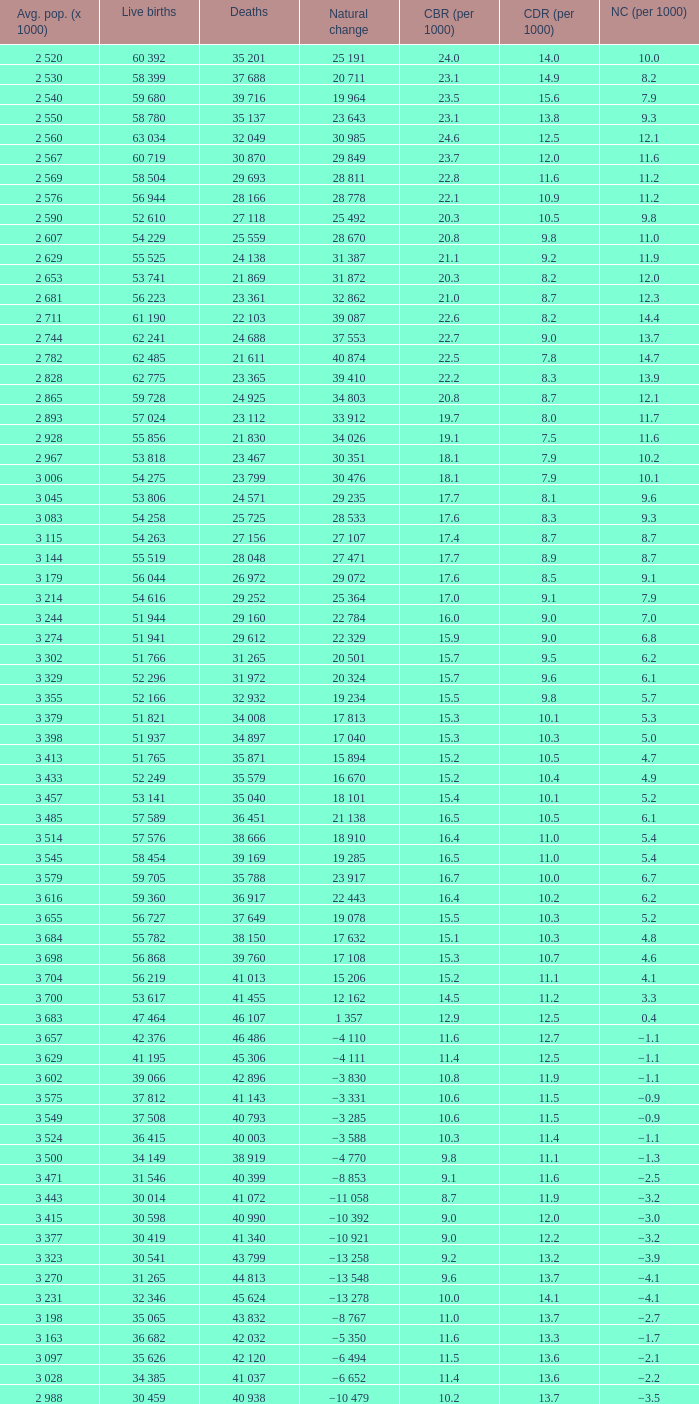Which Average population (x 1000) has a Crude death rate (per 1000) smaller than 10.9, and a Crude birth rate (per 1000) smaller than 19.7, and a Natural change (per 1000) of 8.7, and Live births of 54 263? 3 115. 